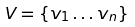Convert formula to latex. <formula><loc_0><loc_0><loc_500><loc_500>V = \{ v _ { 1 } \dots v _ { n } \}</formula> 